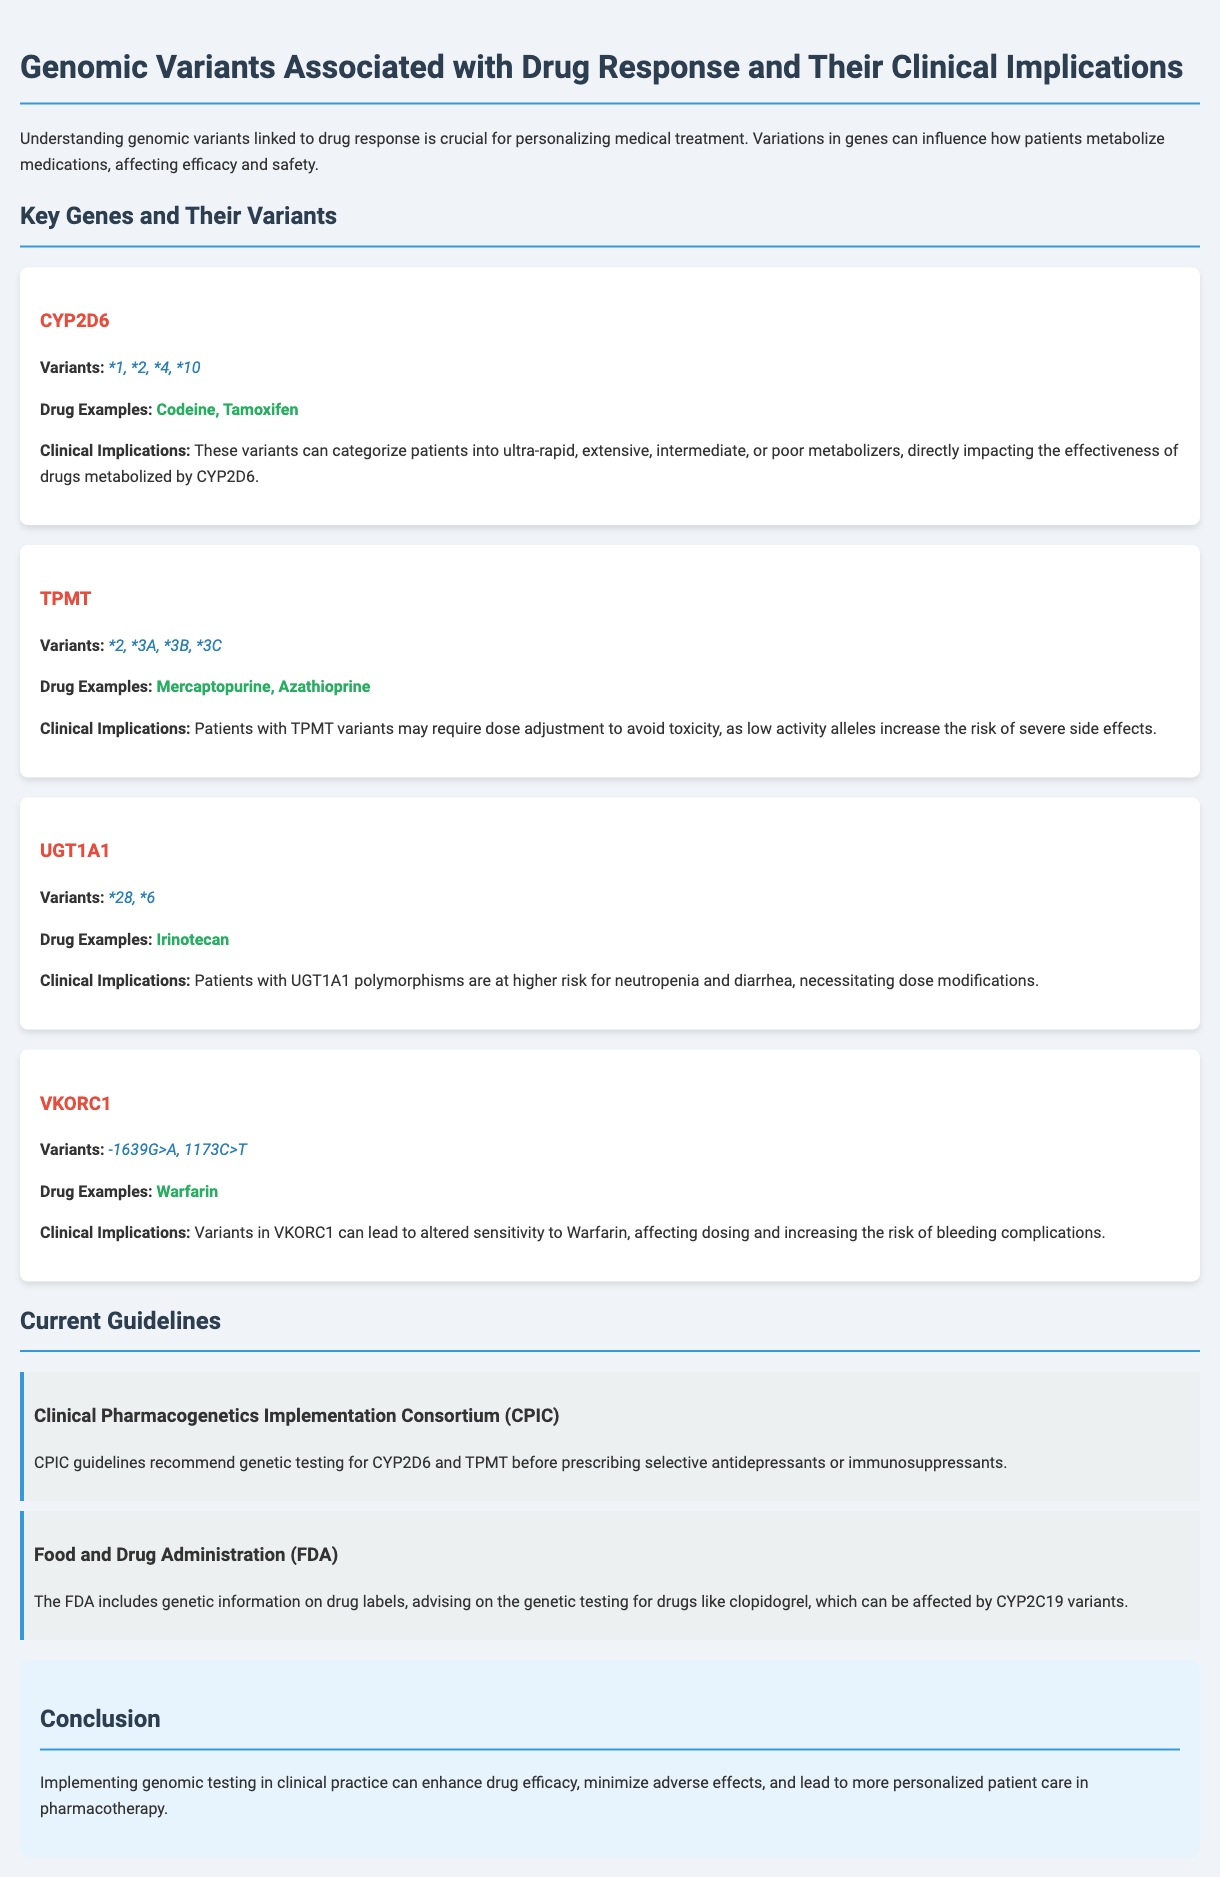What are the variants of CYP2D6? The variants associated with CYP2D6 mentioned in the document are *1, *2, *4, *10.
Answer: *1, *2, *4, *10 What drugs are affected by TPMT variants? The drugs listed that are influenced by TPMT variants include Mercaptopurine and Azathioprine.
Answer: Mercaptopurine, Azathioprine What is the clinical implication of UGT1A1 variants? The document indicates that UGT1A1 polymorphisms increase the risk for neutropenia and diarrhea, necessitating dose modifications.
Answer: Higher risk for neutropenia and diarrhea What is the recommendation by CPIC regarding genetic testing? According to CPIC, genetic testing is recommended for CYP2D6 and TPMT before prescribing certain antidepressants or immunosuppressants.
Answer: For CYP2D6 and TPMT How does VKORC1 affect Warfarin sensitivity? Variants in VKORC1 can lead to altered sensitivity to Warfarin, resulting in dosing changes and increased bleeding risk.
Answer: Altered sensitivity What examples of drugs are mentioned for UGT1A1? The document states that Irinotecan is an example of a drug affected by UGT1A1 variants.
Answer: Irinotecan Which organization provides guidelines for pharmacogenetics? The guidelines mentioned are from the Clinical Pharmacogenetics Implementation Consortium (CPIC).
Answer: Clinical Pharmacogenetics Implementation Consortium (CPIC) What is the purpose of implementing genomic testing according to the conclusion? The conclusion states that implementing genomic testing can enhance drug efficacy and minimize adverse effects, leading to personalized patient care in pharmacotherapy.
Answer: Enhance drug efficacy and minimize adverse effects 